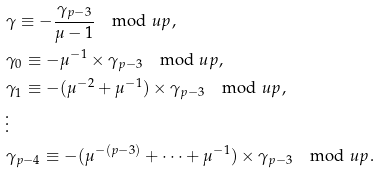<formula> <loc_0><loc_0><loc_500><loc_500>& \gamma \equiv - \frac { \gamma _ { p - 3 } } { \mu - 1 } \mod u p , \\ & \gamma _ { 0 } \equiv - \mu ^ { - 1 } \times \gamma _ { p - 3 } \mod u p , \\ & \gamma _ { 1 } \equiv - ( \mu ^ { - 2 } + \mu ^ { - 1 } ) \times \gamma _ { p - 3 } \mod u p , \\ & \vdots \\ & \gamma _ { p - 4 } \equiv - ( \mu ^ { - ( p - 3 ) } + \dots + \mu ^ { - 1 } ) \times \gamma _ { p - 3 } \mod u p .</formula> 